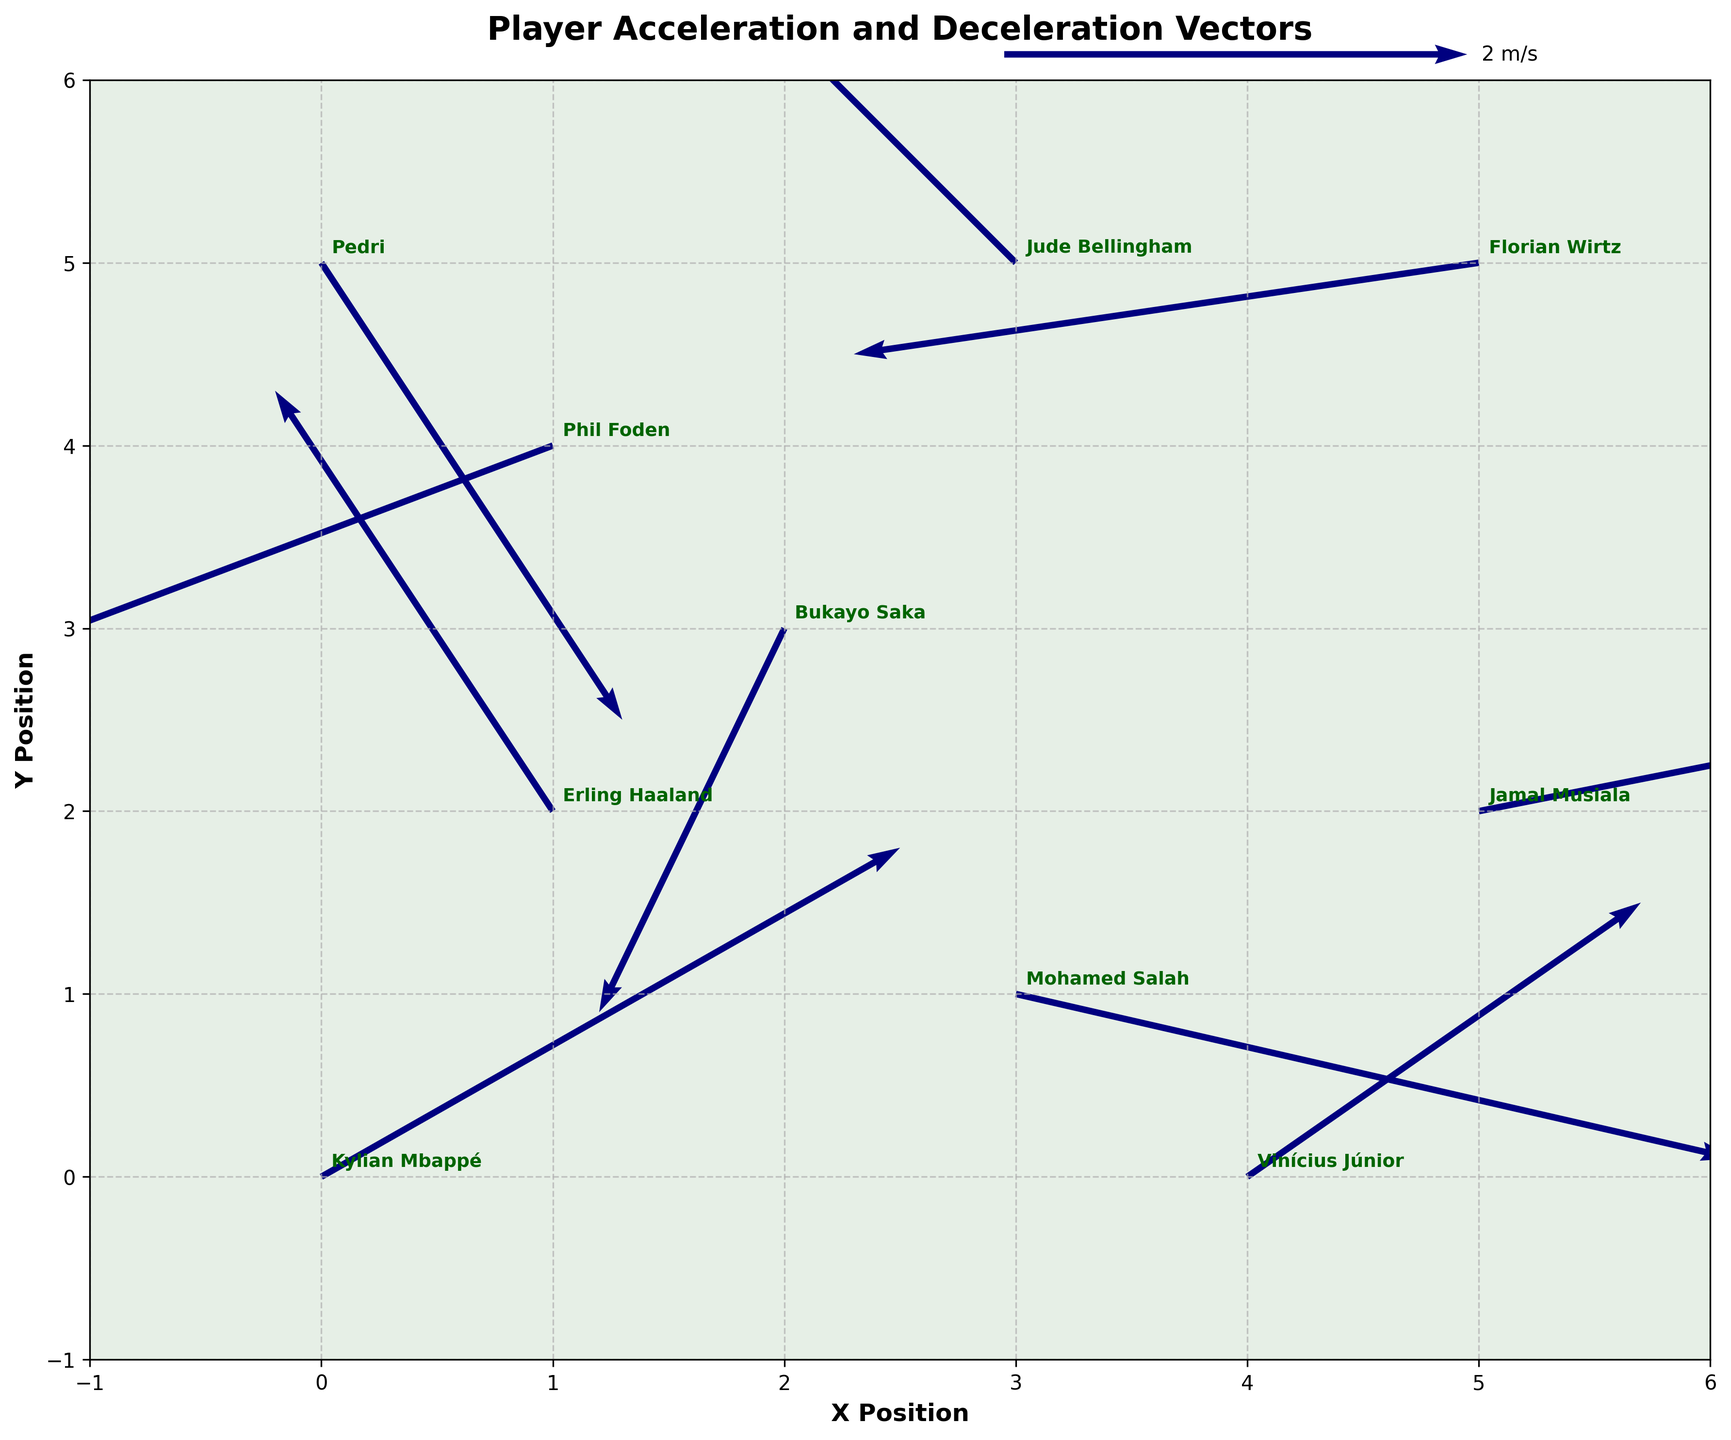Which player has the longest acceleration vector? The longest vector is the one with the largest magnitude. To find this, calculate the magnitude of each vector using the formula √(u² + v²) and compare them. Kylian Mbappé's vector has a magnitude of √(2.5² + 1.8²) ≈ 3.0, which is the largest.
Answer: Kylian Mbappé Which player has the shortest deceleration vector? The shortest vector is the one with the smallest magnitude. Calculate the magnitude of each deceleration vector (negative u or v values) and compare. Pedri's vector has a magnitude of √(1.3² + (-2.5)²) ≈ 2.8; this appears to be the shortest.
Answer: Bukayo Saka What direction does Erling Haaland's vector point to? Erling Haaland's vector has components (-1.2, 2.3), which means it points leftwards and upwards from his starting point.
Answer: Left and Up Which player has the most horizontally oriented vector and what is its direction? A horizontally oriented vector has the smallest vertical component (v). The smallest vertical component belongs to Phil Foden with (-2.3, -1.1). The horizontal component is -2.3, meaning the direction is left.
Answer: Phil Foden, Left Who shows both acceleration and deceleration in their movements during the sprint drills? Players are considered to show both acceleration and deceleration if both their u and v components are positive and negative across the dataset. Kylian Mbappé and Phil Foden show such characteristics in their vectors.
Answer: Kylian Mbappé, Phil Foden How many players' vectors postively incline on the x-axis? A vector's incline is positive on the x-axis if the u component is positive. Check all vectors with positive u components. The players with positive x-components are Kylian Mbappé, Mohamed Salah, Vinícius Júnior, and Jamal Musiala.
Answer: 4 players Compare the directions of Kylian Mbappé and Bukayo Saka's vectors. Which player moves more towards the y-axis? Compare the magnitude of the y-components (v) of each player's vector. Kylian Mbappé has v = 1.8, while Bukayo Saka has v = -2.1. The greater magnitude in Bukayo Saka's vector shows he moves more towards the y-axis despite his negative component.
Answer: Bukayo Saka Of the top two players with the highest acceleration magnitudes, who has the least vertical component? First, identify the players with the highest magnitudes (Kylian Mbappé and Mohamed Salah). Then compare their vertical components. Kylian Mbappé's vertical component is 1.8 and Mohamed Salah's is -0.9.
Answer: Mohamed Salah 